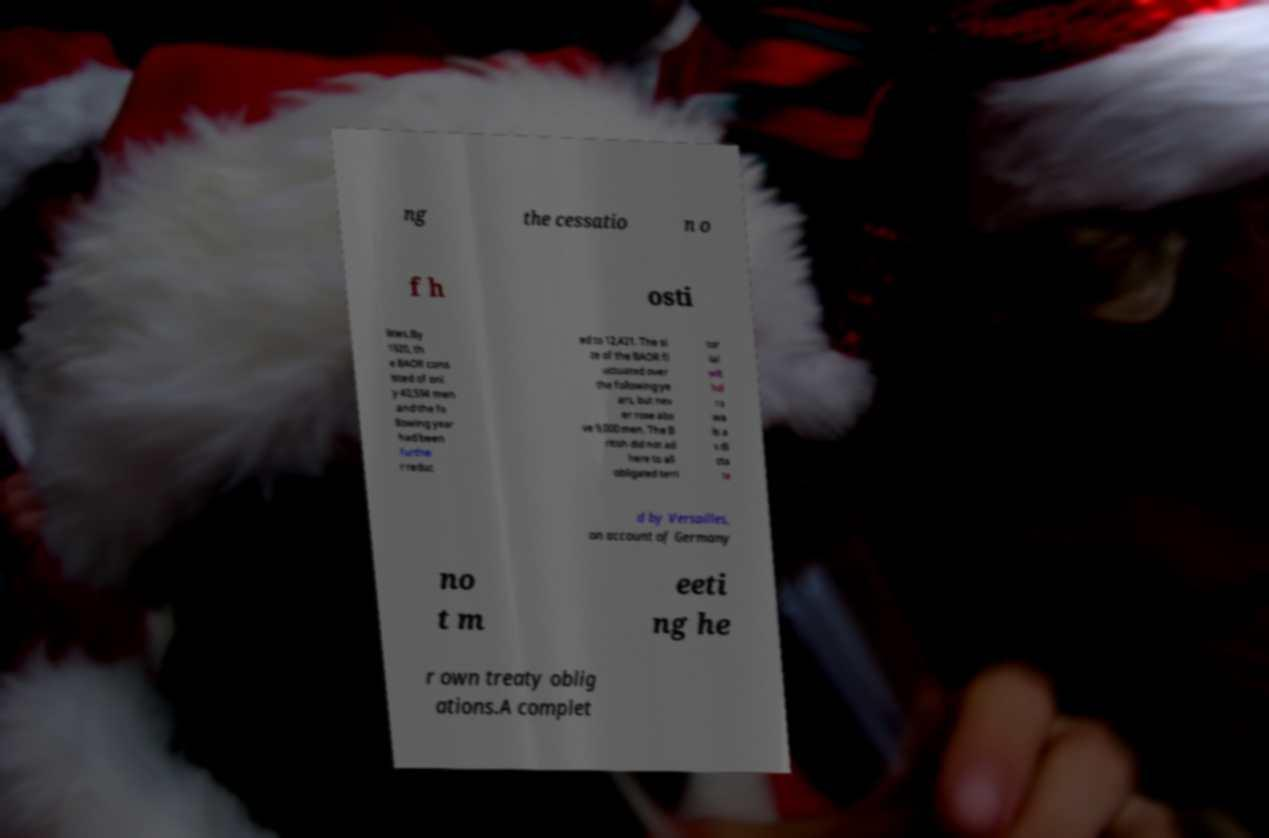Can you read and provide the text displayed in the image?This photo seems to have some interesting text. Can you extract and type it out for me? ng the cessatio n o f h osti lities.By 1920, th e BAOR cons isted of onl y 40,594 men and the fo llowing year had been furthe r reduc ed to 12,421. The si ze of the BAOR fl uctuated over the following ye ars, but nev er rose abo ve 9,000 men. The B ritish did not ad here to all obligated terri tor ial wit hd ra wa ls a s di cta te d by Versailles, on account of Germany no t m eeti ng he r own treaty oblig ations.A complet 